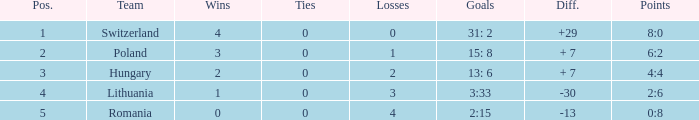Can you parse all the data within this table? {'header': ['Pos.', 'Team', 'Wins', 'Ties', 'Losses', 'Goals', 'Diff.', 'Points'], 'rows': [['1', 'Switzerland', '4', '0', '0', '31: 2', '+29', '8:0'], ['2', 'Poland', '3', '0', '1', '15: 8', '+ 7', '6:2'], ['3', 'Hungary', '2', '0', '2', '13: 6', '+ 7', '4:4'], ['4', 'Lithuania', '1', '0', '3', '3:33', '-30', '2:6'], ['5', 'Romania', '0', '0', '4', '2:15', '-13', '0:8']]} Which team had under 2 losses and a placement number above 1? Poland. 